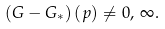Convert formula to latex. <formula><loc_0><loc_0><loc_500><loc_500>\left ( G - G _ { * } \right ) ( p ) \ne 0 , \, \infty .</formula> 